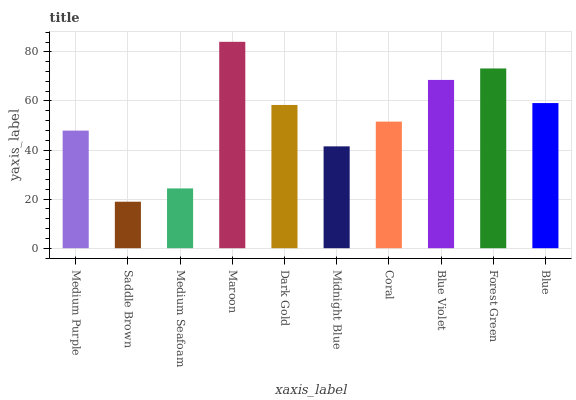Is Saddle Brown the minimum?
Answer yes or no. Yes. Is Maroon the maximum?
Answer yes or no. Yes. Is Medium Seafoam the minimum?
Answer yes or no. No. Is Medium Seafoam the maximum?
Answer yes or no. No. Is Medium Seafoam greater than Saddle Brown?
Answer yes or no. Yes. Is Saddle Brown less than Medium Seafoam?
Answer yes or no. Yes. Is Saddle Brown greater than Medium Seafoam?
Answer yes or no. No. Is Medium Seafoam less than Saddle Brown?
Answer yes or no. No. Is Dark Gold the high median?
Answer yes or no. Yes. Is Coral the low median?
Answer yes or no. Yes. Is Forest Green the high median?
Answer yes or no. No. Is Blue Violet the low median?
Answer yes or no. No. 